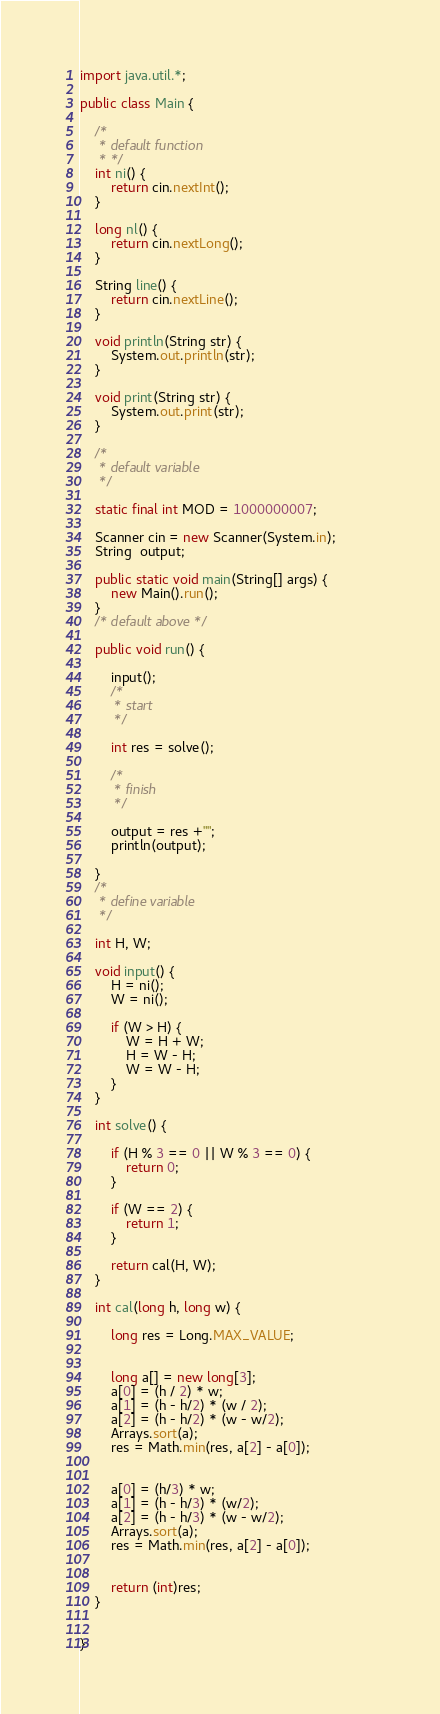<code> <loc_0><loc_0><loc_500><loc_500><_Java_>import java.util.*;

public class Main {
	
	/*
	 * default function
	 * */	
	int ni() {
		return cin.nextInt();
	}
	
	long nl() {
		return cin.nextLong();
	}
	
	String line() {
		return cin.nextLine();
	}
	
	void println(String str) {	
		System.out.println(str);
	}
	
	void print(String str) {
		System.out.print(str);
	}
	
	/*
	 * default variable
	 */
	
	static final int MOD = 1000000007;
	
	Scanner cin = new Scanner(System.in);	
	String  output;
	
	public static void main(String[] args) {			
		new Main().run();						
	}
	/* default above */
		
	public void run() {
			
		input();
		/* 
		 * start
		 */	
		
		int res = solve();
		
		/*
		 * finish
		 */
		
		output = res +"";
		println(output);
			
	}
	/* 
	 * define variable
	 */
	
	int H, W;
	
	void input() {
		H = ni();
		W = ni();
		
		if (W > H) {
			W = H + W;
			H = W - H;
			W = W - H;
		}
	}
	
	int solve() {
		
		if (H % 3 == 0 || W % 3 == 0) {
			return 0;
		}
		
		if (W == 2) {
			return 1;
		}
		
		return cal(H, W);		
	}
	
	int cal(long h, long w) {
		
		long res = Long.MAX_VALUE;
		
		
		long a[] = new long[3];
		a[0] = (h / 2) * w;
		a[1] = (h - h/2) * (w / 2);
		a[2] = (h - h/2) * (w - w/2);
		Arrays.sort(a);
		res = Math.min(res, a[2] - a[0]);
		
		
		a[0] = (h/3) * w;
		a[1] = (h - h/3) * (w/2);
		a[2] = (h - h/3) * (w - w/2);
		Arrays.sort(a);
		res = Math.min(res, a[2] - a[0]);
		
		
		return (int)res;
	}
	
	
}
</code> 